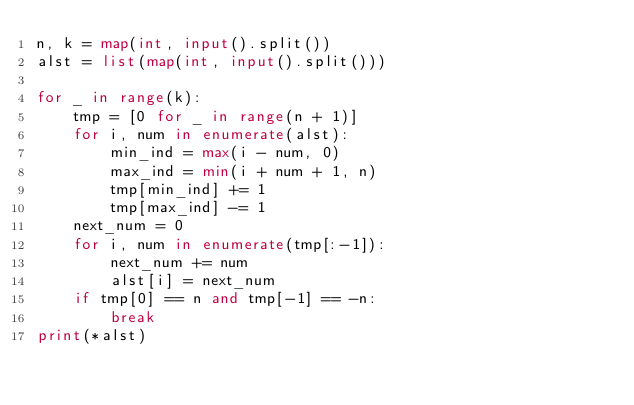Convert code to text. <code><loc_0><loc_0><loc_500><loc_500><_Python_>n, k = map(int, input().split())
alst = list(map(int, input().split()))

for _ in range(k):
    tmp = [0 for _ in range(n + 1)]
    for i, num in enumerate(alst):
        min_ind = max(i - num, 0)
        max_ind = min(i + num + 1, n)
        tmp[min_ind] += 1
        tmp[max_ind] -= 1
    next_num = 0
    for i, num in enumerate(tmp[:-1]):
        next_num += num
        alst[i] = next_num
    if tmp[0] == n and tmp[-1] == -n:
        break
print(*alst)</code> 